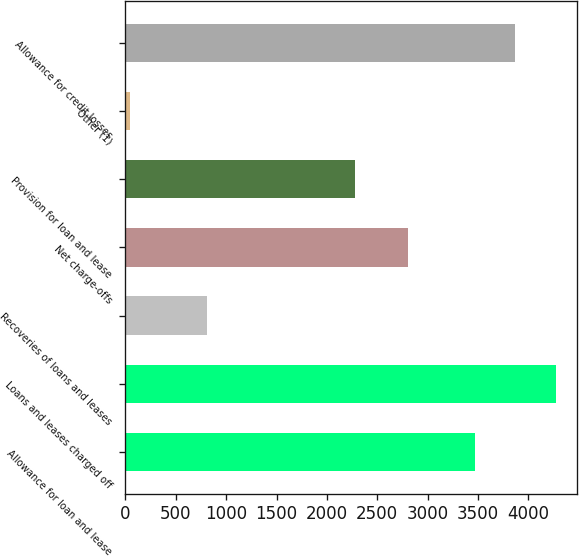<chart> <loc_0><loc_0><loc_500><loc_500><bar_chart><fcel>Allowance for loan and lease<fcel>Loans and leases charged off<fcel>Recoveries of loans and leases<fcel>Net charge-offs<fcel>Provision for loan and lease<fcel>Other (1)<fcel>Allowance for credit losses<nl><fcel>3471<fcel>4271<fcel>813<fcel>2807<fcel>2278<fcel>47<fcel>3871<nl></chart> 